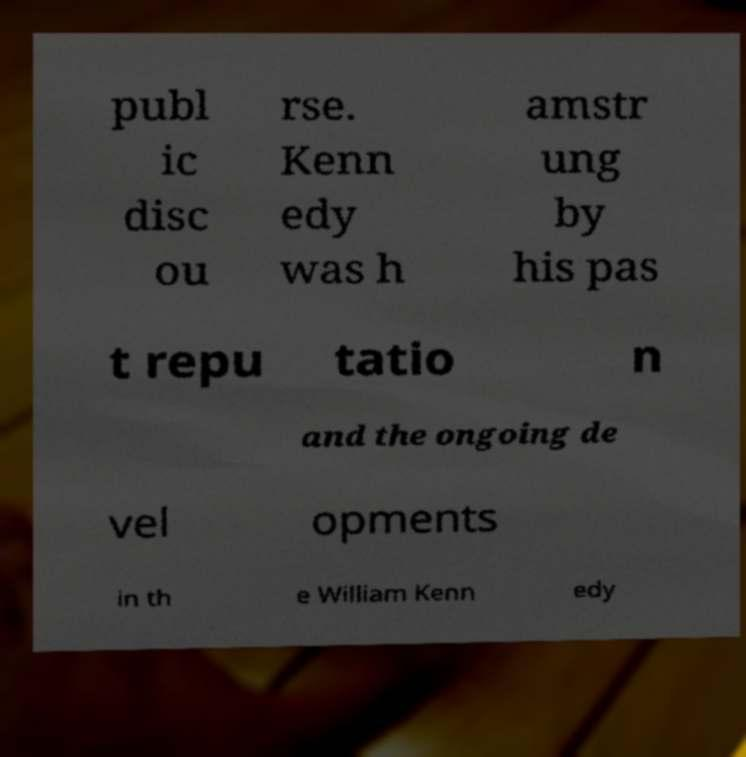I need the written content from this picture converted into text. Can you do that? publ ic disc ou rse. Kenn edy was h amstr ung by his pas t repu tatio n and the ongoing de vel opments in th e William Kenn edy 